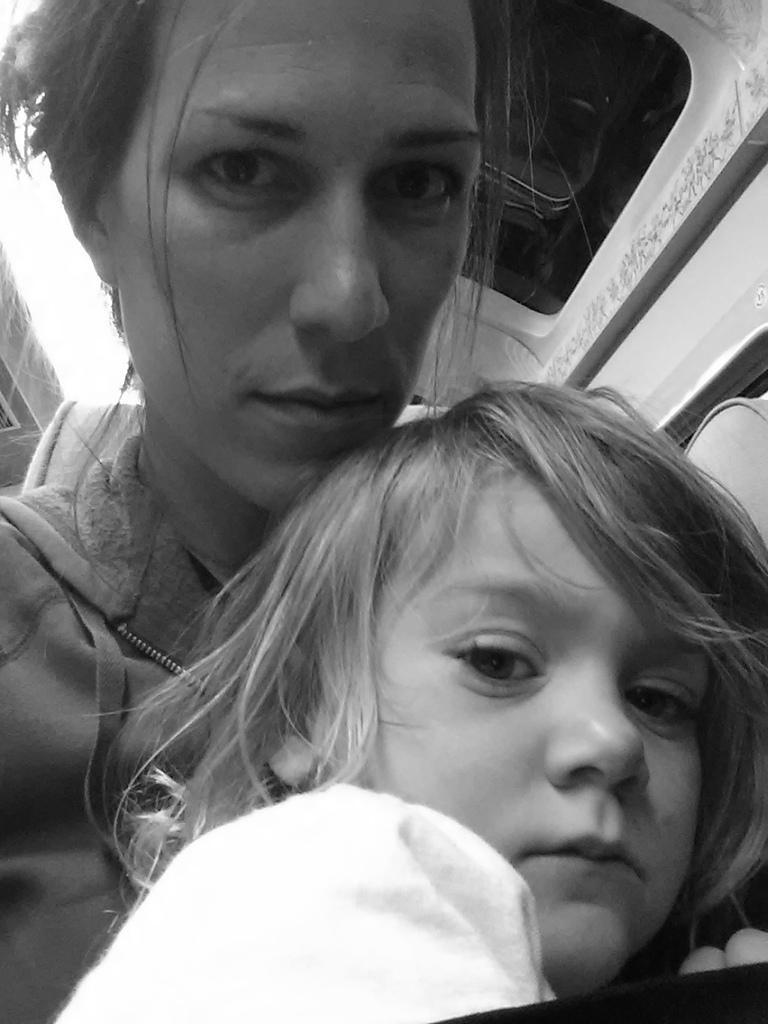Could you give a brief overview of what you see in this image? In this picture I can see a woman and a girl. Looks like woman seated in a vehicle. 